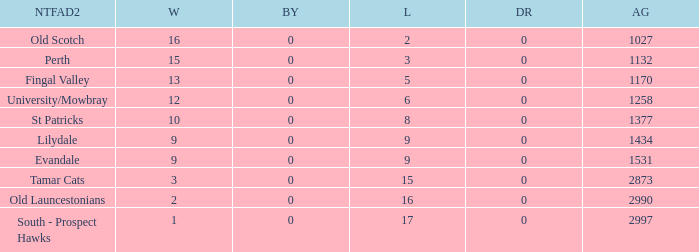What is the lowest number of against of NTFA Div 2 Fingal Valley? 1170.0. 